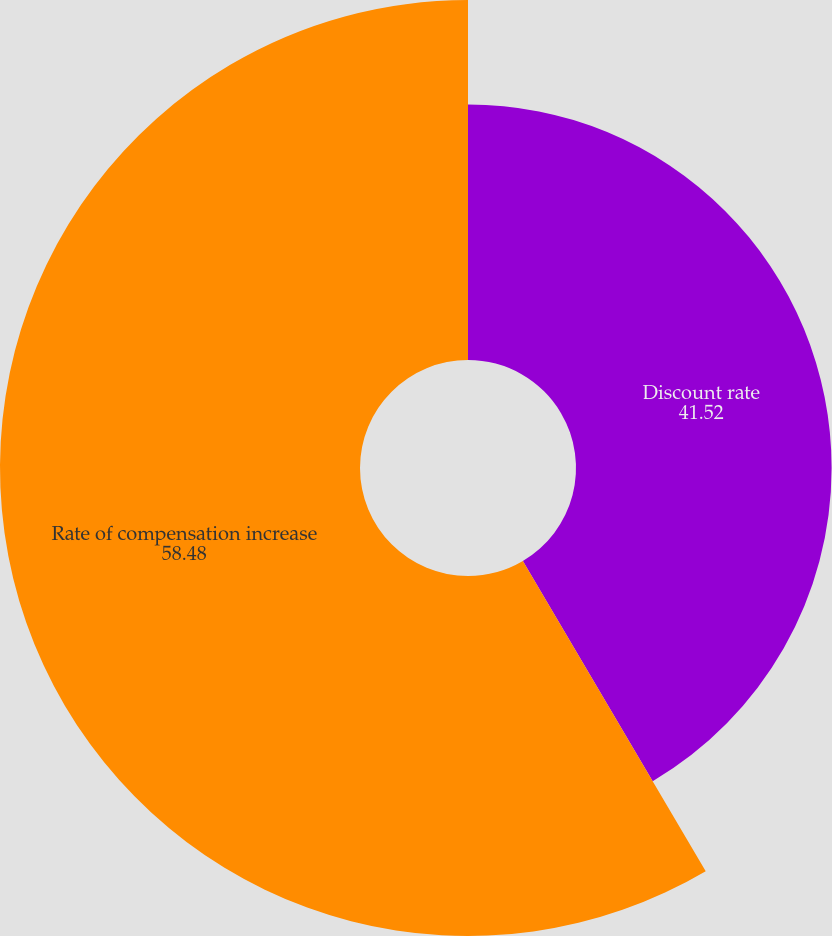Convert chart. <chart><loc_0><loc_0><loc_500><loc_500><pie_chart><fcel>Discount rate<fcel>Rate of compensation increase<nl><fcel>41.52%<fcel>58.48%<nl></chart> 